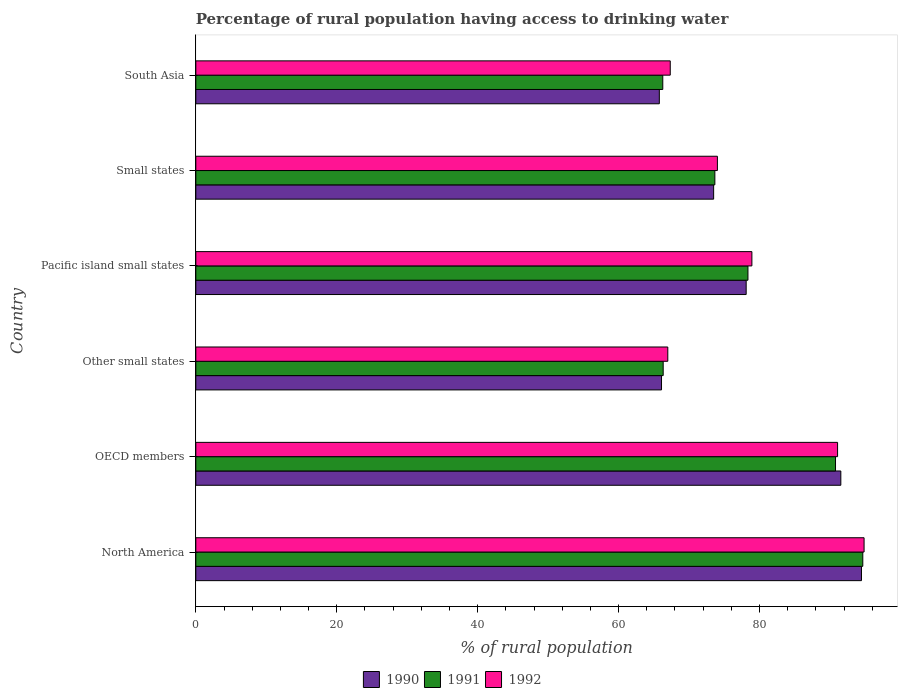How many groups of bars are there?
Offer a very short reply. 6. Are the number of bars per tick equal to the number of legend labels?
Provide a short and direct response. Yes. Are the number of bars on each tick of the Y-axis equal?
Your response must be concise. Yes. What is the label of the 6th group of bars from the top?
Your answer should be compact. North America. In how many cases, is the number of bars for a given country not equal to the number of legend labels?
Give a very brief answer. 0. What is the percentage of rural population having access to drinking water in 1992 in OECD members?
Provide a succinct answer. 91.08. Across all countries, what is the maximum percentage of rural population having access to drinking water in 1991?
Offer a very short reply. 94.66. Across all countries, what is the minimum percentage of rural population having access to drinking water in 1991?
Make the answer very short. 66.28. In which country was the percentage of rural population having access to drinking water in 1992 maximum?
Ensure brevity in your answer.  North America. In which country was the percentage of rural population having access to drinking water in 1992 minimum?
Give a very brief answer. Other small states. What is the total percentage of rural population having access to drinking water in 1991 in the graph?
Your answer should be compact. 470.1. What is the difference between the percentage of rural population having access to drinking water in 1990 in North America and that in South Asia?
Provide a succinct answer. 28.69. What is the difference between the percentage of rural population having access to drinking water in 1991 in Other small states and the percentage of rural population having access to drinking water in 1990 in OECD members?
Your answer should be compact. -25.21. What is the average percentage of rural population having access to drinking water in 1990 per country?
Offer a terse response. 78.25. What is the difference between the percentage of rural population having access to drinking water in 1991 and percentage of rural population having access to drinking water in 1990 in Small states?
Offer a very short reply. 0.17. In how many countries, is the percentage of rural population having access to drinking water in 1991 greater than 72 %?
Your response must be concise. 4. What is the ratio of the percentage of rural population having access to drinking water in 1992 in Other small states to that in Small states?
Your response must be concise. 0.9. What is the difference between the highest and the second highest percentage of rural population having access to drinking water in 1991?
Make the answer very short. 3.87. What is the difference between the highest and the lowest percentage of rural population having access to drinking water in 1990?
Ensure brevity in your answer.  28.69. In how many countries, is the percentage of rural population having access to drinking water in 1991 greater than the average percentage of rural population having access to drinking water in 1991 taken over all countries?
Your answer should be compact. 3. Is the sum of the percentage of rural population having access to drinking water in 1991 in Small states and South Asia greater than the maximum percentage of rural population having access to drinking water in 1992 across all countries?
Keep it short and to the point. Yes. How many bars are there?
Offer a very short reply. 18. How many countries are there in the graph?
Your answer should be compact. 6. What is the difference between two consecutive major ticks on the X-axis?
Your answer should be very brief. 20. Are the values on the major ticks of X-axis written in scientific E-notation?
Make the answer very short. No. Does the graph contain any zero values?
Keep it short and to the point. No. Does the graph contain grids?
Ensure brevity in your answer.  No. What is the title of the graph?
Offer a very short reply. Percentage of rural population having access to drinking water. What is the label or title of the X-axis?
Give a very brief answer. % of rural population. What is the % of rural population of 1990 in North America?
Your answer should be very brief. 94.48. What is the % of rural population in 1991 in North America?
Provide a succinct answer. 94.66. What is the % of rural population in 1992 in North America?
Offer a terse response. 94.85. What is the % of rural population of 1990 in OECD members?
Ensure brevity in your answer.  91.55. What is the % of rural population in 1991 in OECD members?
Provide a short and direct response. 90.79. What is the % of rural population of 1992 in OECD members?
Keep it short and to the point. 91.08. What is the % of rural population of 1990 in Other small states?
Your response must be concise. 66.1. What is the % of rural population of 1991 in Other small states?
Keep it short and to the point. 66.33. What is the % of rural population of 1992 in Other small states?
Provide a short and direct response. 66.99. What is the % of rural population of 1990 in Pacific island small states?
Offer a very short reply. 78.11. What is the % of rural population in 1991 in Pacific island small states?
Offer a very short reply. 78.36. What is the % of rural population of 1992 in Pacific island small states?
Your answer should be very brief. 78.92. What is the % of rural population in 1990 in Small states?
Provide a short and direct response. 73.49. What is the % of rural population of 1991 in Small states?
Offer a very short reply. 73.67. What is the % of rural population of 1992 in Small states?
Your answer should be compact. 74.03. What is the % of rural population of 1990 in South Asia?
Ensure brevity in your answer.  65.79. What is the % of rural population in 1991 in South Asia?
Offer a terse response. 66.28. What is the % of rural population of 1992 in South Asia?
Keep it short and to the point. 67.34. Across all countries, what is the maximum % of rural population of 1990?
Provide a short and direct response. 94.48. Across all countries, what is the maximum % of rural population of 1991?
Make the answer very short. 94.66. Across all countries, what is the maximum % of rural population of 1992?
Offer a very short reply. 94.85. Across all countries, what is the minimum % of rural population of 1990?
Provide a succinct answer. 65.79. Across all countries, what is the minimum % of rural population in 1991?
Your answer should be compact. 66.28. Across all countries, what is the minimum % of rural population of 1992?
Make the answer very short. 66.99. What is the total % of rural population of 1990 in the graph?
Offer a terse response. 469.51. What is the total % of rural population in 1991 in the graph?
Keep it short and to the point. 470.1. What is the total % of rural population of 1992 in the graph?
Your answer should be very brief. 473.21. What is the difference between the % of rural population of 1990 in North America and that in OECD members?
Provide a short and direct response. 2.93. What is the difference between the % of rural population in 1991 in North America and that in OECD members?
Your answer should be compact. 3.87. What is the difference between the % of rural population of 1992 in North America and that in OECD members?
Offer a very short reply. 3.76. What is the difference between the % of rural population of 1990 in North America and that in Other small states?
Your answer should be very brief. 28.38. What is the difference between the % of rural population of 1991 in North America and that in Other small states?
Provide a short and direct response. 28.33. What is the difference between the % of rural population of 1992 in North America and that in Other small states?
Your answer should be very brief. 27.86. What is the difference between the % of rural population in 1990 in North America and that in Pacific island small states?
Keep it short and to the point. 16.37. What is the difference between the % of rural population of 1991 in North America and that in Pacific island small states?
Your answer should be very brief. 16.3. What is the difference between the % of rural population of 1992 in North America and that in Pacific island small states?
Offer a terse response. 15.92. What is the difference between the % of rural population of 1990 in North America and that in Small states?
Offer a very short reply. 20.98. What is the difference between the % of rural population of 1991 in North America and that in Small states?
Make the answer very short. 21. What is the difference between the % of rural population in 1992 in North America and that in Small states?
Offer a terse response. 20.82. What is the difference between the % of rural population in 1990 in North America and that in South Asia?
Offer a terse response. 28.69. What is the difference between the % of rural population of 1991 in North America and that in South Asia?
Ensure brevity in your answer.  28.39. What is the difference between the % of rural population of 1992 in North America and that in South Asia?
Your response must be concise. 27.51. What is the difference between the % of rural population of 1990 in OECD members and that in Other small states?
Your answer should be very brief. 25.45. What is the difference between the % of rural population of 1991 in OECD members and that in Other small states?
Give a very brief answer. 24.46. What is the difference between the % of rural population of 1992 in OECD members and that in Other small states?
Offer a terse response. 24.1. What is the difference between the % of rural population in 1990 in OECD members and that in Pacific island small states?
Give a very brief answer. 13.43. What is the difference between the % of rural population of 1991 in OECD members and that in Pacific island small states?
Your response must be concise. 12.43. What is the difference between the % of rural population of 1992 in OECD members and that in Pacific island small states?
Provide a succinct answer. 12.16. What is the difference between the % of rural population in 1990 in OECD members and that in Small states?
Your response must be concise. 18.05. What is the difference between the % of rural population in 1991 in OECD members and that in Small states?
Give a very brief answer. 17.12. What is the difference between the % of rural population of 1992 in OECD members and that in Small states?
Keep it short and to the point. 17.06. What is the difference between the % of rural population of 1990 in OECD members and that in South Asia?
Your response must be concise. 25.76. What is the difference between the % of rural population of 1991 in OECD members and that in South Asia?
Offer a very short reply. 24.52. What is the difference between the % of rural population of 1992 in OECD members and that in South Asia?
Give a very brief answer. 23.75. What is the difference between the % of rural population in 1990 in Other small states and that in Pacific island small states?
Keep it short and to the point. -12.01. What is the difference between the % of rural population in 1991 in Other small states and that in Pacific island small states?
Keep it short and to the point. -12.03. What is the difference between the % of rural population of 1992 in Other small states and that in Pacific island small states?
Offer a terse response. -11.94. What is the difference between the % of rural population in 1990 in Other small states and that in Small states?
Provide a succinct answer. -7.4. What is the difference between the % of rural population of 1991 in Other small states and that in Small states?
Keep it short and to the point. -7.33. What is the difference between the % of rural population in 1992 in Other small states and that in Small states?
Provide a succinct answer. -7.04. What is the difference between the % of rural population in 1990 in Other small states and that in South Asia?
Your response must be concise. 0.31. What is the difference between the % of rural population of 1991 in Other small states and that in South Asia?
Keep it short and to the point. 0.06. What is the difference between the % of rural population in 1992 in Other small states and that in South Asia?
Give a very brief answer. -0.35. What is the difference between the % of rural population of 1990 in Pacific island small states and that in Small states?
Make the answer very short. 4.62. What is the difference between the % of rural population of 1991 in Pacific island small states and that in Small states?
Provide a succinct answer. 4.7. What is the difference between the % of rural population of 1992 in Pacific island small states and that in Small states?
Your answer should be compact. 4.9. What is the difference between the % of rural population in 1990 in Pacific island small states and that in South Asia?
Keep it short and to the point. 12.33. What is the difference between the % of rural population in 1991 in Pacific island small states and that in South Asia?
Keep it short and to the point. 12.09. What is the difference between the % of rural population in 1992 in Pacific island small states and that in South Asia?
Provide a short and direct response. 11.59. What is the difference between the % of rural population in 1990 in Small states and that in South Asia?
Make the answer very short. 7.71. What is the difference between the % of rural population in 1991 in Small states and that in South Asia?
Ensure brevity in your answer.  7.39. What is the difference between the % of rural population in 1992 in Small states and that in South Asia?
Ensure brevity in your answer.  6.69. What is the difference between the % of rural population in 1990 in North America and the % of rural population in 1991 in OECD members?
Your answer should be compact. 3.69. What is the difference between the % of rural population of 1990 in North America and the % of rural population of 1992 in OECD members?
Your response must be concise. 3.39. What is the difference between the % of rural population in 1991 in North America and the % of rural population in 1992 in OECD members?
Keep it short and to the point. 3.58. What is the difference between the % of rural population of 1990 in North America and the % of rural population of 1991 in Other small states?
Keep it short and to the point. 28.14. What is the difference between the % of rural population of 1990 in North America and the % of rural population of 1992 in Other small states?
Ensure brevity in your answer.  27.49. What is the difference between the % of rural population of 1991 in North America and the % of rural population of 1992 in Other small states?
Make the answer very short. 27.68. What is the difference between the % of rural population in 1990 in North America and the % of rural population in 1991 in Pacific island small states?
Provide a succinct answer. 16.11. What is the difference between the % of rural population of 1990 in North America and the % of rural population of 1992 in Pacific island small states?
Your answer should be compact. 15.55. What is the difference between the % of rural population of 1991 in North America and the % of rural population of 1992 in Pacific island small states?
Make the answer very short. 15.74. What is the difference between the % of rural population in 1990 in North America and the % of rural population in 1991 in Small states?
Keep it short and to the point. 20.81. What is the difference between the % of rural population of 1990 in North America and the % of rural population of 1992 in Small states?
Ensure brevity in your answer.  20.45. What is the difference between the % of rural population in 1991 in North America and the % of rural population in 1992 in Small states?
Give a very brief answer. 20.64. What is the difference between the % of rural population in 1990 in North America and the % of rural population in 1991 in South Asia?
Provide a short and direct response. 28.2. What is the difference between the % of rural population of 1990 in North America and the % of rural population of 1992 in South Asia?
Provide a short and direct response. 27.14. What is the difference between the % of rural population in 1991 in North America and the % of rural population in 1992 in South Asia?
Provide a short and direct response. 27.33. What is the difference between the % of rural population of 1990 in OECD members and the % of rural population of 1991 in Other small states?
Your response must be concise. 25.21. What is the difference between the % of rural population in 1990 in OECD members and the % of rural population in 1992 in Other small states?
Give a very brief answer. 24.56. What is the difference between the % of rural population of 1991 in OECD members and the % of rural population of 1992 in Other small states?
Provide a short and direct response. 23.8. What is the difference between the % of rural population in 1990 in OECD members and the % of rural population in 1991 in Pacific island small states?
Give a very brief answer. 13.18. What is the difference between the % of rural population of 1990 in OECD members and the % of rural population of 1992 in Pacific island small states?
Your answer should be compact. 12.62. What is the difference between the % of rural population of 1991 in OECD members and the % of rural population of 1992 in Pacific island small states?
Your answer should be very brief. 11.87. What is the difference between the % of rural population in 1990 in OECD members and the % of rural population in 1991 in Small states?
Offer a terse response. 17.88. What is the difference between the % of rural population in 1990 in OECD members and the % of rural population in 1992 in Small states?
Provide a short and direct response. 17.52. What is the difference between the % of rural population in 1991 in OECD members and the % of rural population in 1992 in Small states?
Provide a succinct answer. 16.76. What is the difference between the % of rural population in 1990 in OECD members and the % of rural population in 1991 in South Asia?
Give a very brief answer. 25.27. What is the difference between the % of rural population in 1990 in OECD members and the % of rural population in 1992 in South Asia?
Ensure brevity in your answer.  24.21. What is the difference between the % of rural population of 1991 in OECD members and the % of rural population of 1992 in South Asia?
Ensure brevity in your answer.  23.46. What is the difference between the % of rural population of 1990 in Other small states and the % of rural population of 1991 in Pacific island small states?
Your answer should be very brief. -12.27. What is the difference between the % of rural population in 1990 in Other small states and the % of rural population in 1992 in Pacific island small states?
Your response must be concise. -12.83. What is the difference between the % of rural population in 1991 in Other small states and the % of rural population in 1992 in Pacific island small states?
Give a very brief answer. -12.59. What is the difference between the % of rural population in 1990 in Other small states and the % of rural population in 1991 in Small states?
Keep it short and to the point. -7.57. What is the difference between the % of rural population of 1990 in Other small states and the % of rural population of 1992 in Small states?
Provide a short and direct response. -7.93. What is the difference between the % of rural population of 1991 in Other small states and the % of rural population of 1992 in Small states?
Your response must be concise. -7.7. What is the difference between the % of rural population of 1990 in Other small states and the % of rural population of 1991 in South Asia?
Offer a terse response. -0.18. What is the difference between the % of rural population in 1990 in Other small states and the % of rural population in 1992 in South Asia?
Your response must be concise. -1.24. What is the difference between the % of rural population in 1991 in Other small states and the % of rural population in 1992 in South Asia?
Keep it short and to the point. -1. What is the difference between the % of rural population in 1990 in Pacific island small states and the % of rural population in 1991 in Small states?
Give a very brief answer. 4.44. What is the difference between the % of rural population in 1990 in Pacific island small states and the % of rural population in 1992 in Small states?
Make the answer very short. 4.08. What is the difference between the % of rural population of 1991 in Pacific island small states and the % of rural population of 1992 in Small states?
Keep it short and to the point. 4.34. What is the difference between the % of rural population in 1990 in Pacific island small states and the % of rural population in 1991 in South Asia?
Ensure brevity in your answer.  11.84. What is the difference between the % of rural population of 1990 in Pacific island small states and the % of rural population of 1992 in South Asia?
Provide a succinct answer. 10.78. What is the difference between the % of rural population of 1991 in Pacific island small states and the % of rural population of 1992 in South Asia?
Provide a short and direct response. 11.03. What is the difference between the % of rural population in 1990 in Small states and the % of rural population in 1991 in South Asia?
Your answer should be very brief. 7.22. What is the difference between the % of rural population of 1990 in Small states and the % of rural population of 1992 in South Asia?
Ensure brevity in your answer.  6.16. What is the difference between the % of rural population in 1991 in Small states and the % of rural population in 1992 in South Asia?
Your response must be concise. 6.33. What is the average % of rural population in 1990 per country?
Make the answer very short. 78.25. What is the average % of rural population in 1991 per country?
Your answer should be very brief. 78.35. What is the average % of rural population in 1992 per country?
Your response must be concise. 78.87. What is the difference between the % of rural population of 1990 and % of rural population of 1991 in North America?
Your response must be concise. -0.19. What is the difference between the % of rural population in 1990 and % of rural population in 1992 in North America?
Your answer should be compact. -0.37. What is the difference between the % of rural population of 1991 and % of rural population of 1992 in North America?
Your answer should be very brief. -0.18. What is the difference between the % of rural population of 1990 and % of rural population of 1991 in OECD members?
Provide a short and direct response. 0.75. What is the difference between the % of rural population in 1990 and % of rural population in 1992 in OECD members?
Provide a succinct answer. 0.46. What is the difference between the % of rural population in 1991 and % of rural population in 1992 in OECD members?
Your answer should be very brief. -0.29. What is the difference between the % of rural population in 1990 and % of rural population in 1991 in Other small states?
Offer a very short reply. -0.24. What is the difference between the % of rural population of 1990 and % of rural population of 1992 in Other small states?
Your answer should be compact. -0.89. What is the difference between the % of rural population in 1991 and % of rural population in 1992 in Other small states?
Offer a terse response. -0.65. What is the difference between the % of rural population in 1990 and % of rural population in 1991 in Pacific island small states?
Ensure brevity in your answer.  -0.25. What is the difference between the % of rural population of 1990 and % of rural population of 1992 in Pacific island small states?
Provide a succinct answer. -0.81. What is the difference between the % of rural population in 1991 and % of rural population in 1992 in Pacific island small states?
Provide a short and direct response. -0.56. What is the difference between the % of rural population of 1990 and % of rural population of 1991 in Small states?
Offer a very short reply. -0.17. What is the difference between the % of rural population of 1990 and % of rural population of 1992 in Small states?
Your answer should be compact. -0.53. What is the difference between the % of rural population of 1991 and % of rural population of 1992 in Small states?
Give a very brief answer. -0.36. What is the difference between the % of rural population of 1990 and % of rural population of 1991 in South Asia?
Give a very brief answer. -0.49. What is the difference between the % of rural population in 1990 and % of rural population in 1992 in South Asia?
Provide a succinct answer. -1.55. What is the difference between the % of rural population in 1991 and % of rural population in 1992 in South Asia?
Provide a succinct answer. -1.06. What is the ratio of the % of rural population of 1990 in North America to that in OECD members?
Give a very brief answer. 1.03. What is the ratio of the % of rural population in 1991 in North America to that in OECD members?
Provide a short and direct response. 1.04. What is the ratio of the % of rural population of 1992 in North America to that in OECD members?
Give a very brief answer. 1.04. What is the ratio of the % of rural population in 1990 in North America to that in Other small states?
Offer a terse response. 1.43. What is the ratio of the % of rural population of 1991 in North America to that in Other small states?
Offer a terse response. 1.43. What is the ratio of the % of rural population of 1992 in North America to that in Other small states?
Ensure brevity in your answer.  1.42. What is the ratio of the % of rural population of 1990 in North America to that in Pacific island small states?
Provide a short and direct response. 1.21. What is the ratio of the % of rural population in 1991 in North America to that in Pacific island small states?
Offer a very short reply. 1.21. What is the ratio of the % of rural population of 1992 in North America to that in Pacific island small states?
Offer a terse response. 1.2. What is the ratio of the % of rural population of 1990 in North America to that in Small states?
Ensure brevity in your answer.  1.29. What is the ratio of the % of rural population in 1991 in North America to that in Small states?
Provide a succinct answer. 1.28. What is the ratio of the % of rural population in 1992 in North America to that in Small states?
Give a very brief answer. 1.28. What is the ratio of the % of rural population in 1990 in North America to that in South Asia?
Provide a succinct answer. 1.44. What is the ratio of the % of rural population of 1991 in North America to that in South Asia?
Ensure brevity in your answer.  1.43. What is the ratio of the % of rural population in 1992 in North America to that in South Asia?
Provide a succinct answer. 1.41. What is the ratio of the % of rural population of 1990 in OECD members to that in Other small states?
Offer a terse response. 1.39. What is the ratio of the % of rural population of 1991 in OECD members to that in Other small states?
Offer a terse response. 1.37. What is the ratio of the % of rural population of 1992 in OECD members to that in Other small states?
Offer a terse response. 1.36. What is the ratio of the % of rural population in 1990 in OECD members to that in Pacific island small states?
Ensure brevity in your answer.  1.17. What is the ratio of the % of rural population in 1991 in OECD members to that in Pacific island small states?
Your answer should be compact. 1.16. What is the ratio of the % of rural population of 1992 in OECD members to that in Pacific island small states?
Give a very brief answer. 1.15. What is the ratio of the % of rural population of 1990 in OECD members to that in Small states?
Offer a terse response. 1.25. What is the ratio of the % of rural population of 1991 in OECD members to that in Small states?
Make the answer very short. 1.23. What is the ratio of the % of rural population in 1992 in OECD members to that in Small states?
Offer a terse response. 1.23. What is the ratio of the % of rural population of 1990 in OECD members to that in South Asia?
Ensure brevity in your answer.  1.39. What is the ratio of the % of rural population of 1991 in OECD members to that in South Asia?
Provide a short and direct response. 1.37. What is the ratio of the % of rural population of 1992 in OECD members to that in South Asia?
Keep it short and to the point. 1.35. What is the ratio of the % of rural population in 1990 in Other small states to that in Pacific island small states?
Ensure brevity in your answer.  0.85. What is the ratio of the % of rural population in 1991 in Other small states to that in Pacific island small states?
Provide a short and direct response. 0.85. What is the ratio of the % of rural population of 1992 in Other small states to that in Pacific island small states?
Provide a short and direct response. 0.85. What is the ratio of the % of rural population of 1990 in Other small states to that in Small states?
Provide a short and direct response. 0.9. What is the ratio of the % of rural population in 1991 in Other small states to that in Small states?
Your response must be concise. 0.9. What is the ratio of the % of rural population in 1992 in Other small states to that in Small states?
Your answer should be compact. 0.9. What is the ratio of the % of rural population of 1990 in Other small states to that in South Asia?
Your answer should be compact. 1. What is the ratio of the % of rural population in 1991 in Other small states to that in South Asia?
Provide a short and direct response. 1. What is the ratio of the % of rural population in 1990 in Pacific island small states to that in Small states?
Make the answer very short. 1.06. What is the ratio of the % of rural population of 1991 in Pacific island small states to that in Small states?
Provide a short and direct response. 1.06. What is the ratio of the % of rural population of 1992 in Pacific island small states to that in Small states?
Offer a very short reply. 1.07. What is the ratio of the % of rural population of 1990 in Pacific island small states to that in South Asia?
Ensure brevity in your answer.  1.19. What is the ratio of the % of rural population of 1991 in Pacific island small states to that in South Asia?
Your answer should be very brief. 1.18. What is the ratio of the % of rural population in 1992 in Pacific island small states to that in South Asia?
Your response must be concise. 1.17. What is the ratio of the % of rural population in 1990 in Small states to that in South Asia?
Keep it short and to the point. 1.12. What is the ratio of the % of rural population of 1991 in Small states to that in South Asia?
Offer a very short reply. 1.11. What is the ratio of the % of rural population of 1992 in Small states to that in South Asia?
Offer a very short reply. 1.1. What is the difference between the highest and the second highest % of rural population of 1990?
Provide a succinct answer. 2.93. What is the difference between the highest and the second highest % of rural population of 1991?
Offer a terse response. 3.87. What is the difference between the highest and the second highest % of rural population in 1992?
Keep it short and to the point. 3.76. What is the difference between the highest and the lowest % of rural population of 1990?
Provide a succinct answer. 28.69. What is the difference between the highest and the lowest % of rural population in 1991?
Offer a terse response. 28.39. What is the difference between the highest and the lowest % of rural population of 1992?
Your answer should be very brief. 27.86. 